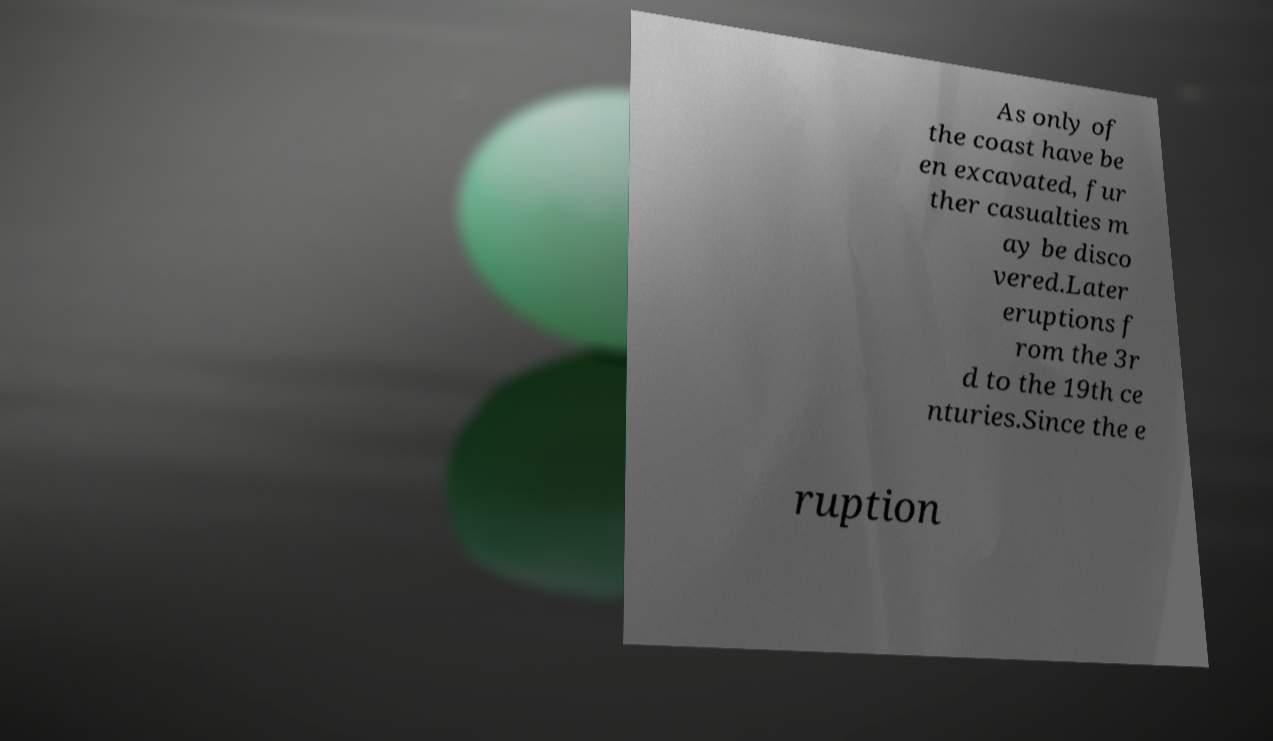Can you read and provide the text displayed in the image?This photo seems to have some interesting text. Can you extract and type it out for me? As only of the coast have be en excavated, fur ther casualties m ay be disco vered.Later eruptions f rom the 3r d to the 19th ce nturies.Since the e ruption 